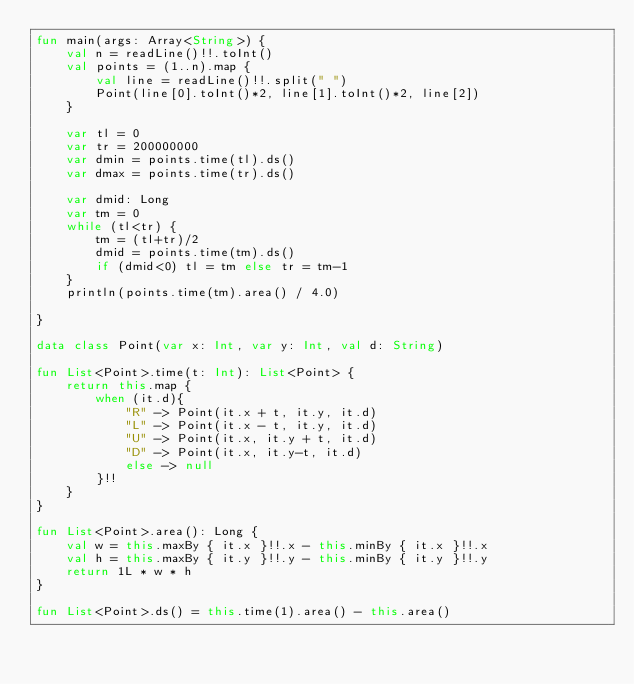Convert code to text. <code><loc_0><loc_0><loc_500><loc_500><_Kotlin_>fun main(args: Array<String>) {
    val n = readLine()!!.toInt()
    val points = (1..n).map {
        val line = readLine()!!.split(" ")
        Point(line[0].toInt()*2, line[1].toInt()*2, line[2])
    }
    
    var tl = 0
    var tr = 200000000
    var dmin = points.time(tl).ds()
    var dmax = points.time(tr).ds()

    var dmid: Long
    var tm = 0
    while (tl<tr) {
        tm = (tl+tr)/2
        dmid = points.time(tm).ds()
        if (dmid<0) tl = tm else tr = tm-1
    }
    println(points.time(tm).area() / 4.0)

}

data class Point(var x: Int, var y: Int, val d: String)

fun List<Point>.time(t: Int): List<Point> {
    return this.map {
        when (it.d){
            "R" -> Point(it.x + t, it.y, it.d)
            "L" -> Point(it.x - t, it.y, it.d)
            "U" -> Point(it.x, it.y + t, it.d)
            "D" -> Point(it.x, it.y-t, it.d)
            else -> null
        }!!
    }
}

fun List<Point>.area(): Long {
    val w = this.maxBy { it.x }!!.x - this.minBy { it.x }!!.x
    val h = this.maxBy { it.y }!!.y - this.minBy { it.y }!!.y
    return 1L * w * h
}

fun List<Point>.ds() = this.time(1).area() - this.area()</code> 